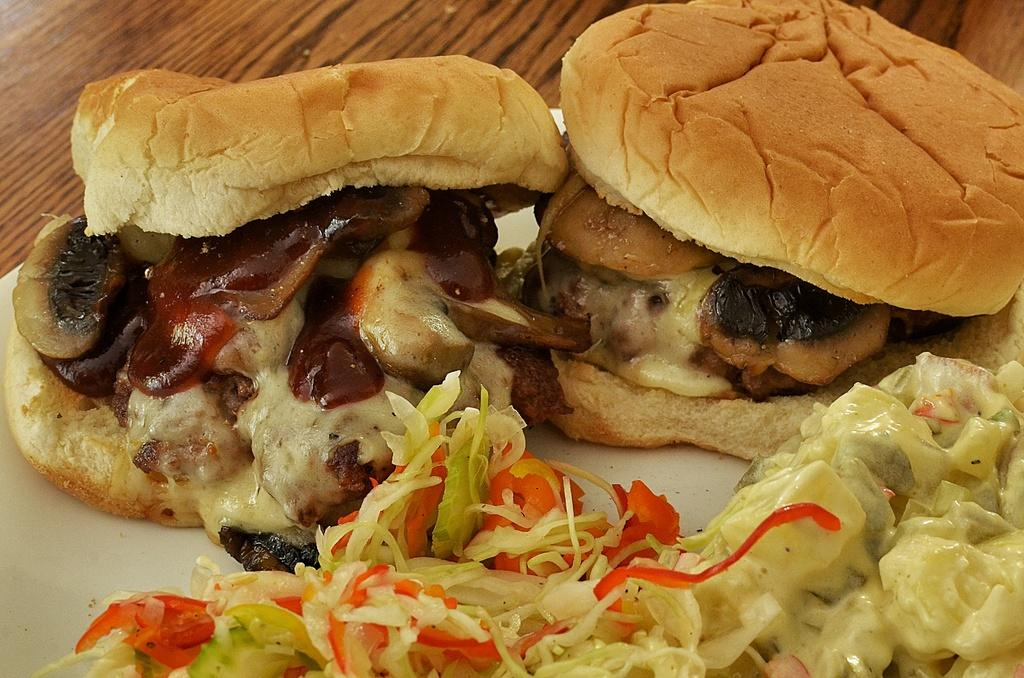How many burgers are visible in the image? There are two burgers in the image. What else can be seen on the plate in the image? There are food items on a plate in the image. What is the plate resting on in the image? The plate is on a wooden board. How many giants are visible in the image? There are no giants present in the image. What type of body is visible in the image? There is no body present in the image; it features two burgers, food items on a plate, and a wooden board. 